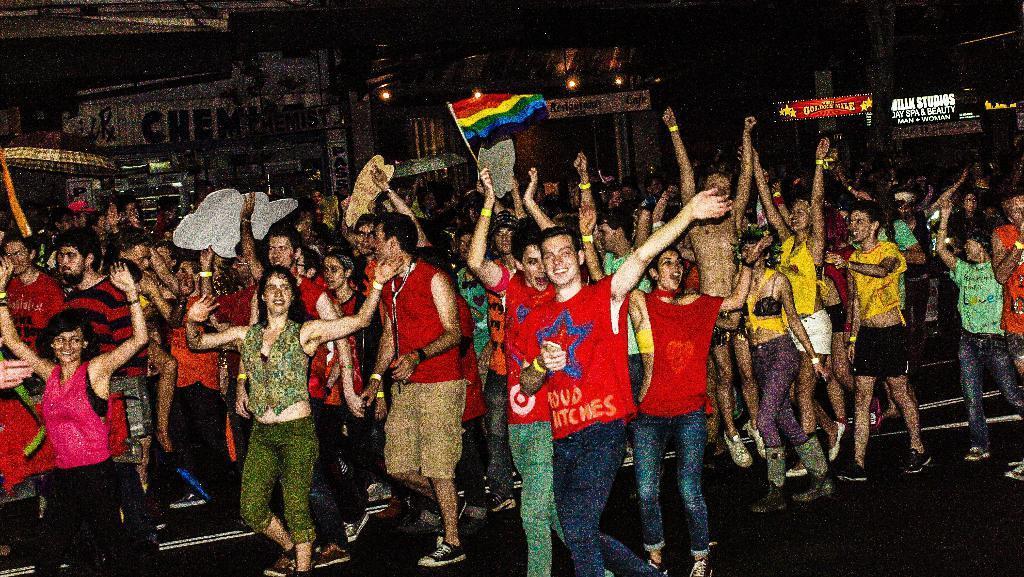Please provide a concise description of this image. In this image, we can see a group of people are dancing, walking and smiling on the road. Few people are holding some objects. Background we can see shops, hoardings, walls, lights. 